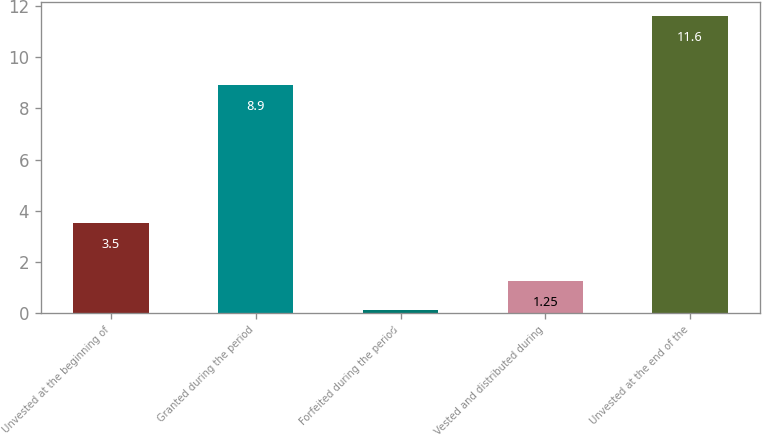Convert chart to OTSL. <chart><loc_0><loc_0><loc_500><loc_500><bar_chart><fcel>Unvested at the beginning of<fcel>Granted during the period<fcel>Forfeited during the period<fcel>Vested and distributed during<fcel>Unvested at the end of the<nl><fcel>3.5<fcel>8.9<fcel>0.1<fcel>1.25<fcel>11.6<nl></chart> 